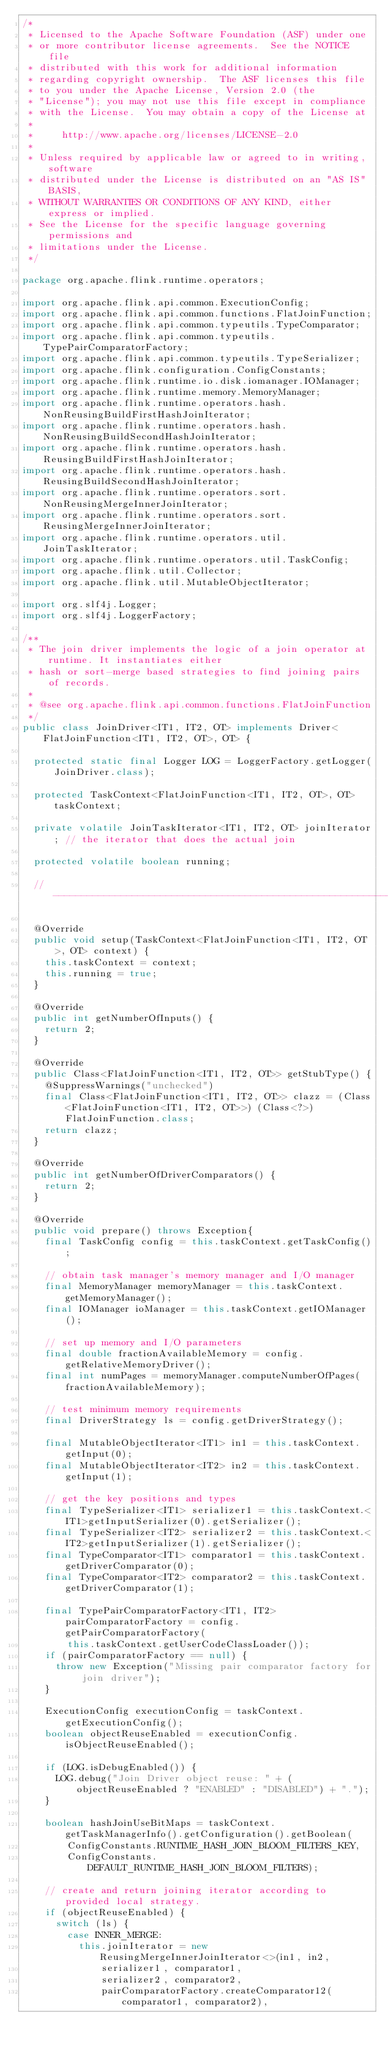<code> <loc_0><loc_0><loc_500><loc_500><_Java_>/*
 * Licensed to the Apache Software Foundation (ASF) under one
 * or more contributor license agreements.  See the NOTICE file
 * distributed with this work for additional information
 * regarding copyright ownership.  The ASF licenses this file
 * to you under the Apache License, Version 2.0 (the
 * "License"); you may not use this file except in compliance
 * with the License.  You may obtain a copy of the License at
 *
 *     http://www.apache.org/licenses/LICENSE-2.0
 *
 * Unless required by applicable law or agreed to in writing, software
 * distributed under the License is distributed on an "AS IS" BASIS,
 * WITHOUT WARRANTIES OR CONDITIONS OF ANY KIND, either express or implied.
 * See the License for the specific language governing permissions and
 * limitations under the License.
 */

package org.apache.flink.runtime.operators;

import org.apache.flink.api.common.ExecutionConfig;
import org.apache.flink.api.common.functions.FlatJoinFunction;
import org.apache.flink.api.common.typeutils.TypeComparator;
import org.apache.flink.api.common.typeutils.TypePairComparatorFactory;
import org.apache.flink.api.common.typeutils.TypeSerializer;
import org.apache.flink.configuration.ConfigConstants;
import org.apache.flink.runtime.io.disk.iomanager.IOManager;
import org.apache.flink.runtime.memory.MemoryManager;
import org.apache.flink.runtime.operators.hash.NonReusingBuildFirstHashJoinIterator;
import org.apache.flink.runtime.operators.hash.NonReusingBuildSecondHashJoinIterator;
import org.apache.flink.runtime.operators.hash.ReusingBuildFirstHashJoinIterator;
import org.apache.flink.runtime.operators.hash.ReusingBuildSecondHashJoinIterator;
import org.apache.flink.runtime.operators.sort.NonReusingMergeInnerJoinIterator;
import org.apache.flink.runtime.operators.sort.ReusingMergeInnerJoinIterator;
import org.apache.flink.runtime.operators.util.JoinTaskIterator;
import org.apache.flink.runtime.operators.util.TaskConfig;
import org.apache.flink.util.Collector;
import org.apache.flink.util.MutableObjectIterator;

import org.slf4j.Logger;
import org.slf4j.LoggerFactory;

/**
 * The join driver implements the logic of a join operator at runtime. It instantiates either
 * hash or sort-merge based strategies to find joining pairs of records.
 * 
 * @see org.apache.flink.api.common.functions.FlatJoinFunction
 */
public class JoinDriver<IT1, IT2, OT> implements Driver<FlatJoinFunction<IT1, IT2, OT>, OT> {
	
	protected static final Logger LOG = LoggerFactory.getLogger(JoinDriver.class);
	
	protected TaskContext<FlatJoinFunction<IT1, IT2, OT>, OT> taskContext;
	
	private volatile JoinTaskIterator<IT1, IT2, OT> joinIterator; // the iterator that does the actual join 
	
	protected volatile boolean running;

	// ------------------------------------------------------------------------

	@Override
	public void setup(TaskContext<FlatJoinFunction<IT1, IT2, OT>, OT> context) {
		this.taskContext = context;
		this.running = true;
	}

	@Override
	public int getNumberOfInputs() {
		return 2;
	}

	@Override
	public Class<FlatJoinFunction<IT1, IT2, OT>> getStubType() {
		@SuppressWarnings("unchecked")
		final Class<FlatJoinFunction<IT1, IT2, OT>> clazz = (Class<FlatJoinFunction<IT1, IT2, OT>>) (Class<?>) FlatJoinFunction.class;
		return clazz;
	}
	
	@Override
	public int getNumberOfDriverComparators() {
		return 2;
	}

	@Override
	public void prepare() throws Exception{
		final TaskConfig config = this.taskContext.getTaskConfig();
		
		// obtain task manager's memory manager and I/O manager
		final MemoryManager memoryManager = this.taskContext.getMemoryManager();
		final IOManager ioManager = this.taskContext.getIOManager();
		
		// set up memory and I/O parameters
		final double fractionAvailableMemory = config.getRelativeMemoryDriver();
		final int numPages = memoryManager.computeNumberOfPages(fractionAvailableMemory);
		
		// test minimum memory requirements
		final DriverStrategy ls = config.getDriverStrategy();
		
		final MutableObjectIterator<IT1> in1 = this.taskContext.getInput(0);
		final MutableObjectIterator<IT2> in2 = this.taskContext.getInput(1);

		// get the key positions and types
		final TypeSerializer<IT1> serializer1 = this.taskContext.<IT1>getInputSerializer(0).getSerializer();
		final TypeSerializer<IT2> serializer2 = this.taskContext.<IT2>getInputSerializer(1).getSerializer();
		final TypeComparator<IT1> comparator1 = this.taskContext.getDriverComparator(0);
		final TypeComparator<IT2> comparator2 = this.taskContext.getDriverComparator(1);
		
		final TypePairComparatorFactory<IT1, IT2> pairComparatorFactory = config.getPairComparatorFactory(
				this.taskContext.getUserCodeClassLoader());
		if (pairComparatorFactory == null) {
			throw new Exception("Missing pair comparator factory for join driver");
		}

		ExecutionConfig executionConfig = taskContext.getExecutionConfig();
		boolean objectReuseEnabled = executionConfig.isObjectReuseEnabled();

		if (LOG.isDebugEnabled()) {
			LOG.debug("Join Driver object reuse: " + (objectReuseEnabled ? "ENABLED" : "DISABLED") + ".");
		}
		
		boolean hashJoinUseBitMaps = taskContext.getTaskManagerInfo().getConfiguration().getBoolean(
				ConfigConstants.RUNTIME_HASH_JOIN_BLOOM_FILTERS_KEY,
				ConfigConstants.DEFAULT_RUNTIME_HASH_JOIN_BLOOM_FILTERS);

		// create and return joining iterator according to provided local strategy.
		if (objectReuseEnabled) {
			switch (ls) {
				case INNER_MERGE:
					this.joinIterator = new ReusingMergeInnerJoinIterator<>(in1, in2, 
							serializer1, comparator1,
							serializer2, comparator2,
							pairComparatorFactory.createComparator12(comparator1, comparator2),</code> 